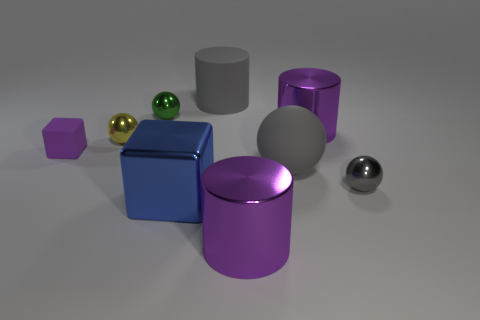Subtract all large matte balls. How many balls are left? 3 Add 1 small yellow shiny balls. How many objects exist? 10 Subtract all blue cubes. How many gray balls are left? 2 Subtract all green spheres. How many spheres are left? 3 Subtract 1 cylinders. How many cylinders are left? 2 Subtract all yellow metallic things. Subtract all big blocks. How many objects are left? 7 Add 6 tiny green metallic things. How many tiny green metallic things are left? 7 Add 6 large blue shiny things. How many large blue shiny things exist? 7 Subtract 1 purple blocks. How many objects are left? 8 Subtract all cylinders. How many objects are left? 6 